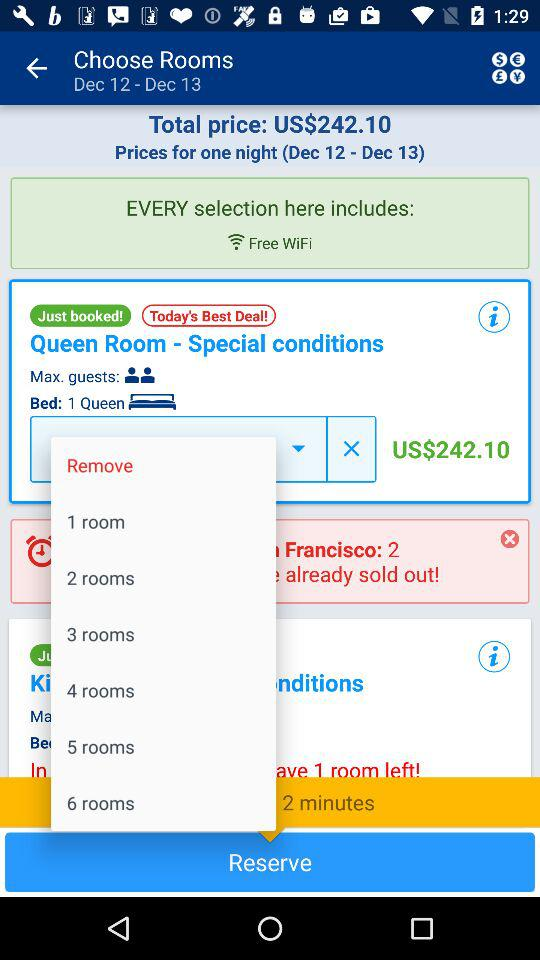For which dates will the rooms be booked? The rooms will be booked for December 12 and December 13. 